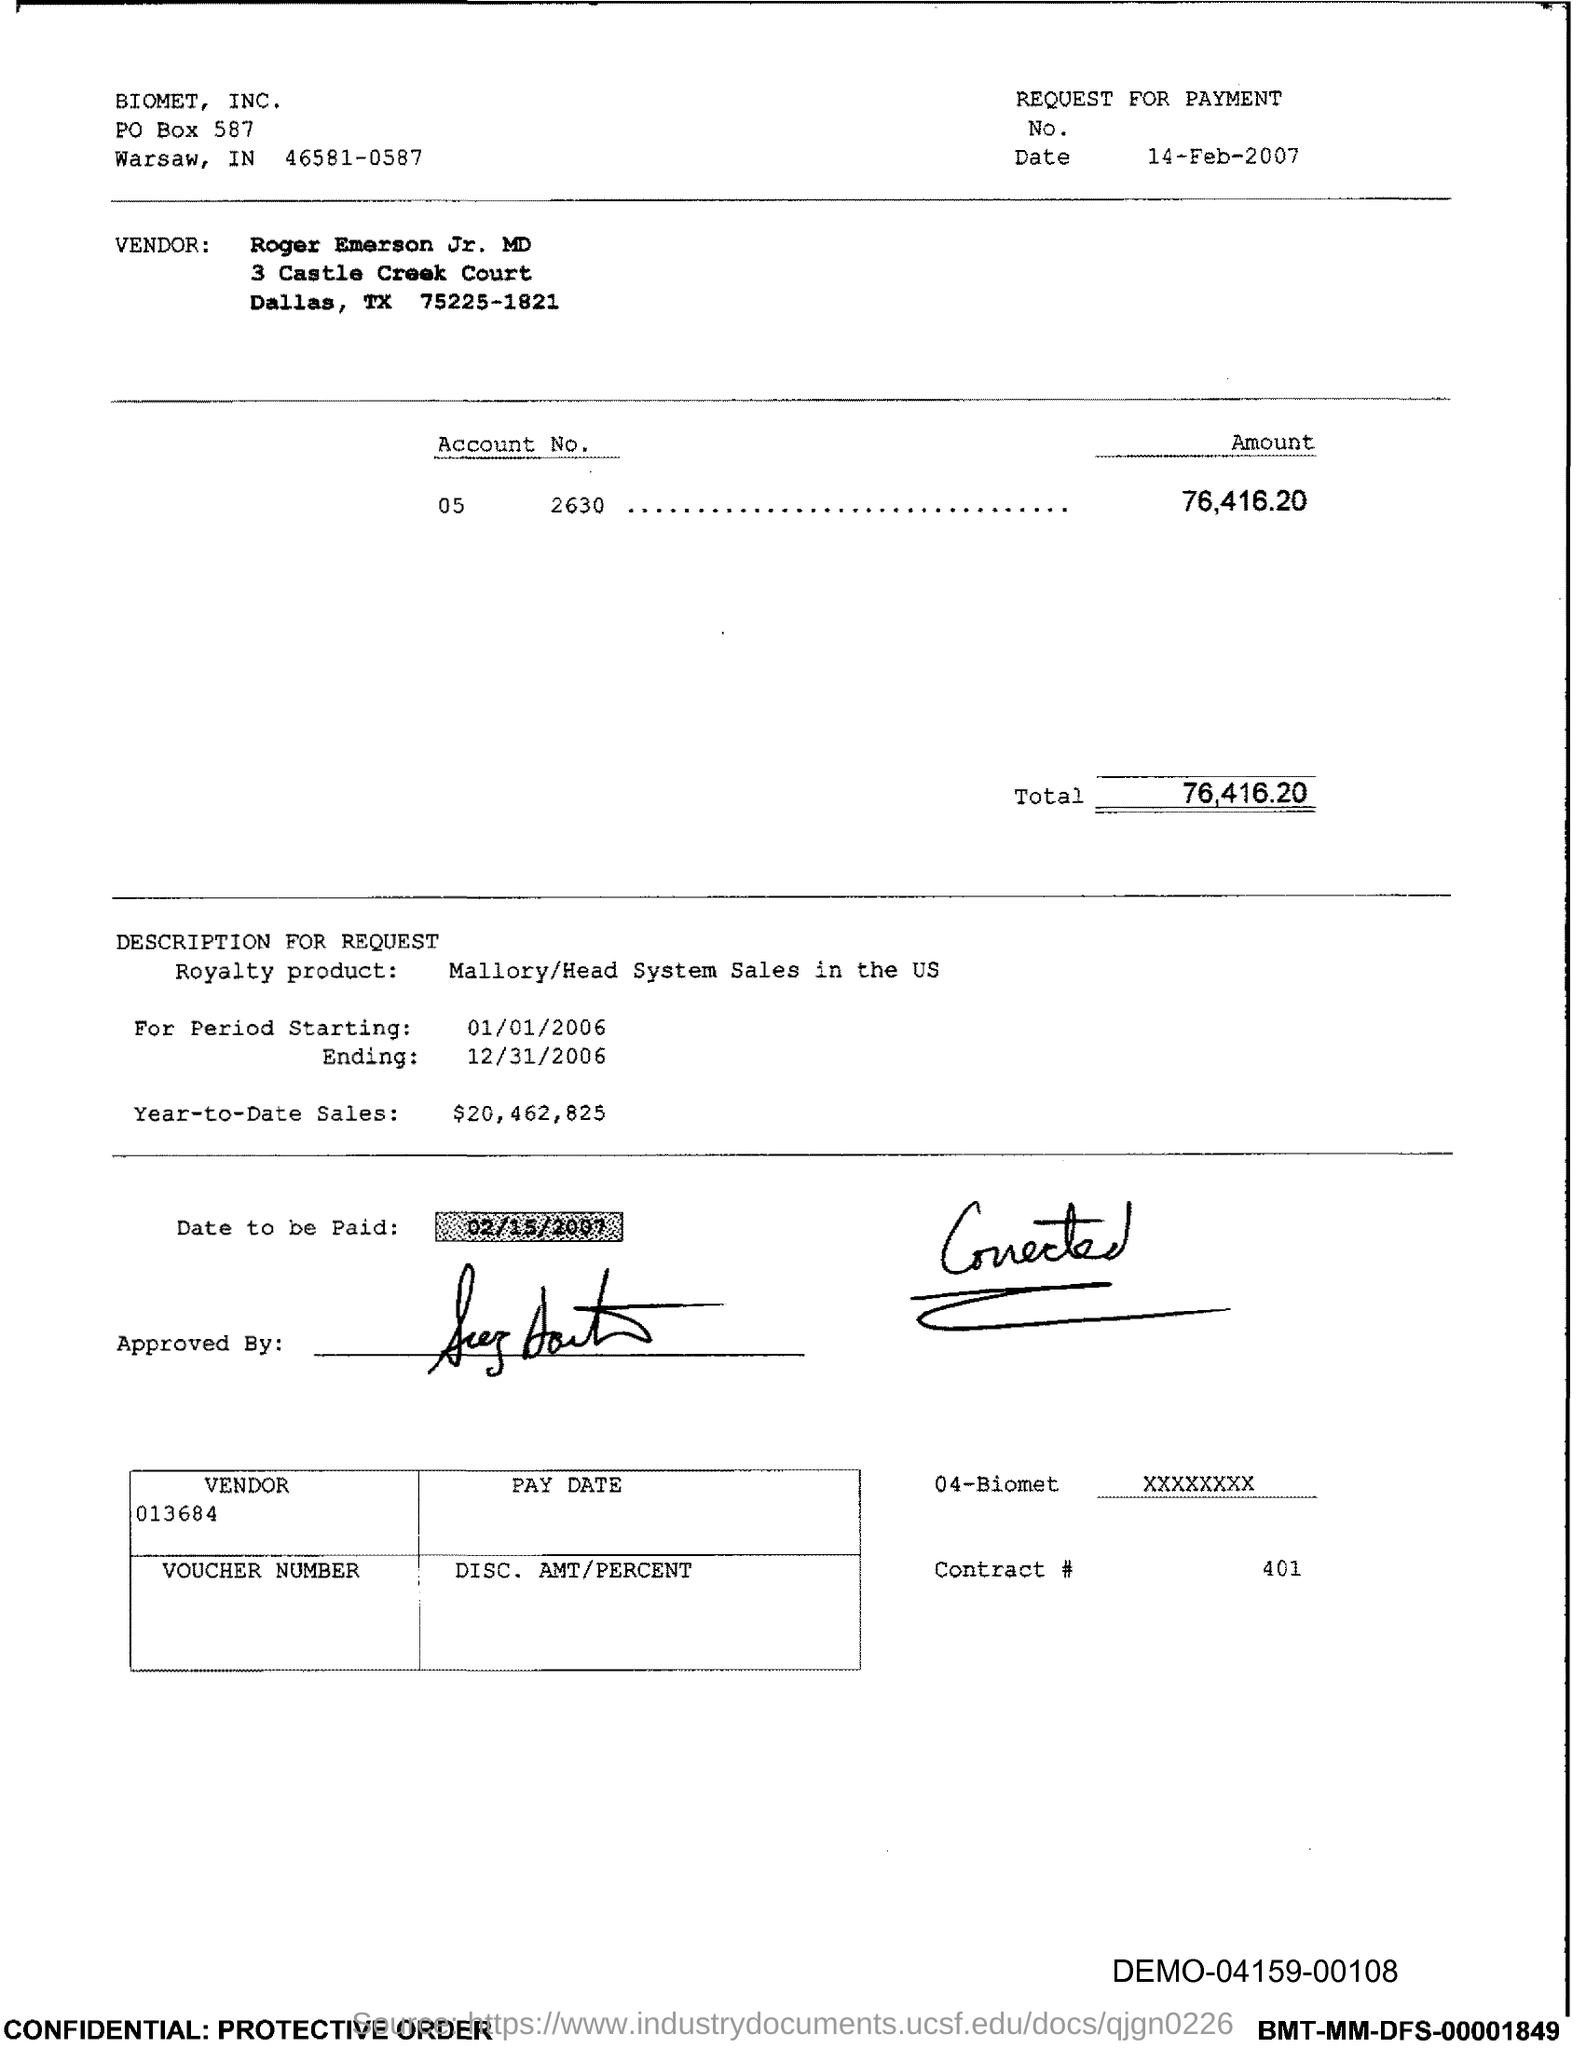Point out several critical features in this image. The date mentioned under "REQUEST FOR PAYMENT" is February 14, 2007. The period starting date is January 1, 2006. The "Account No." mentioned in the text is 052630. The period ending date is December 31, 2006. The PO BOX number of Biomet, Inc. is 587. 